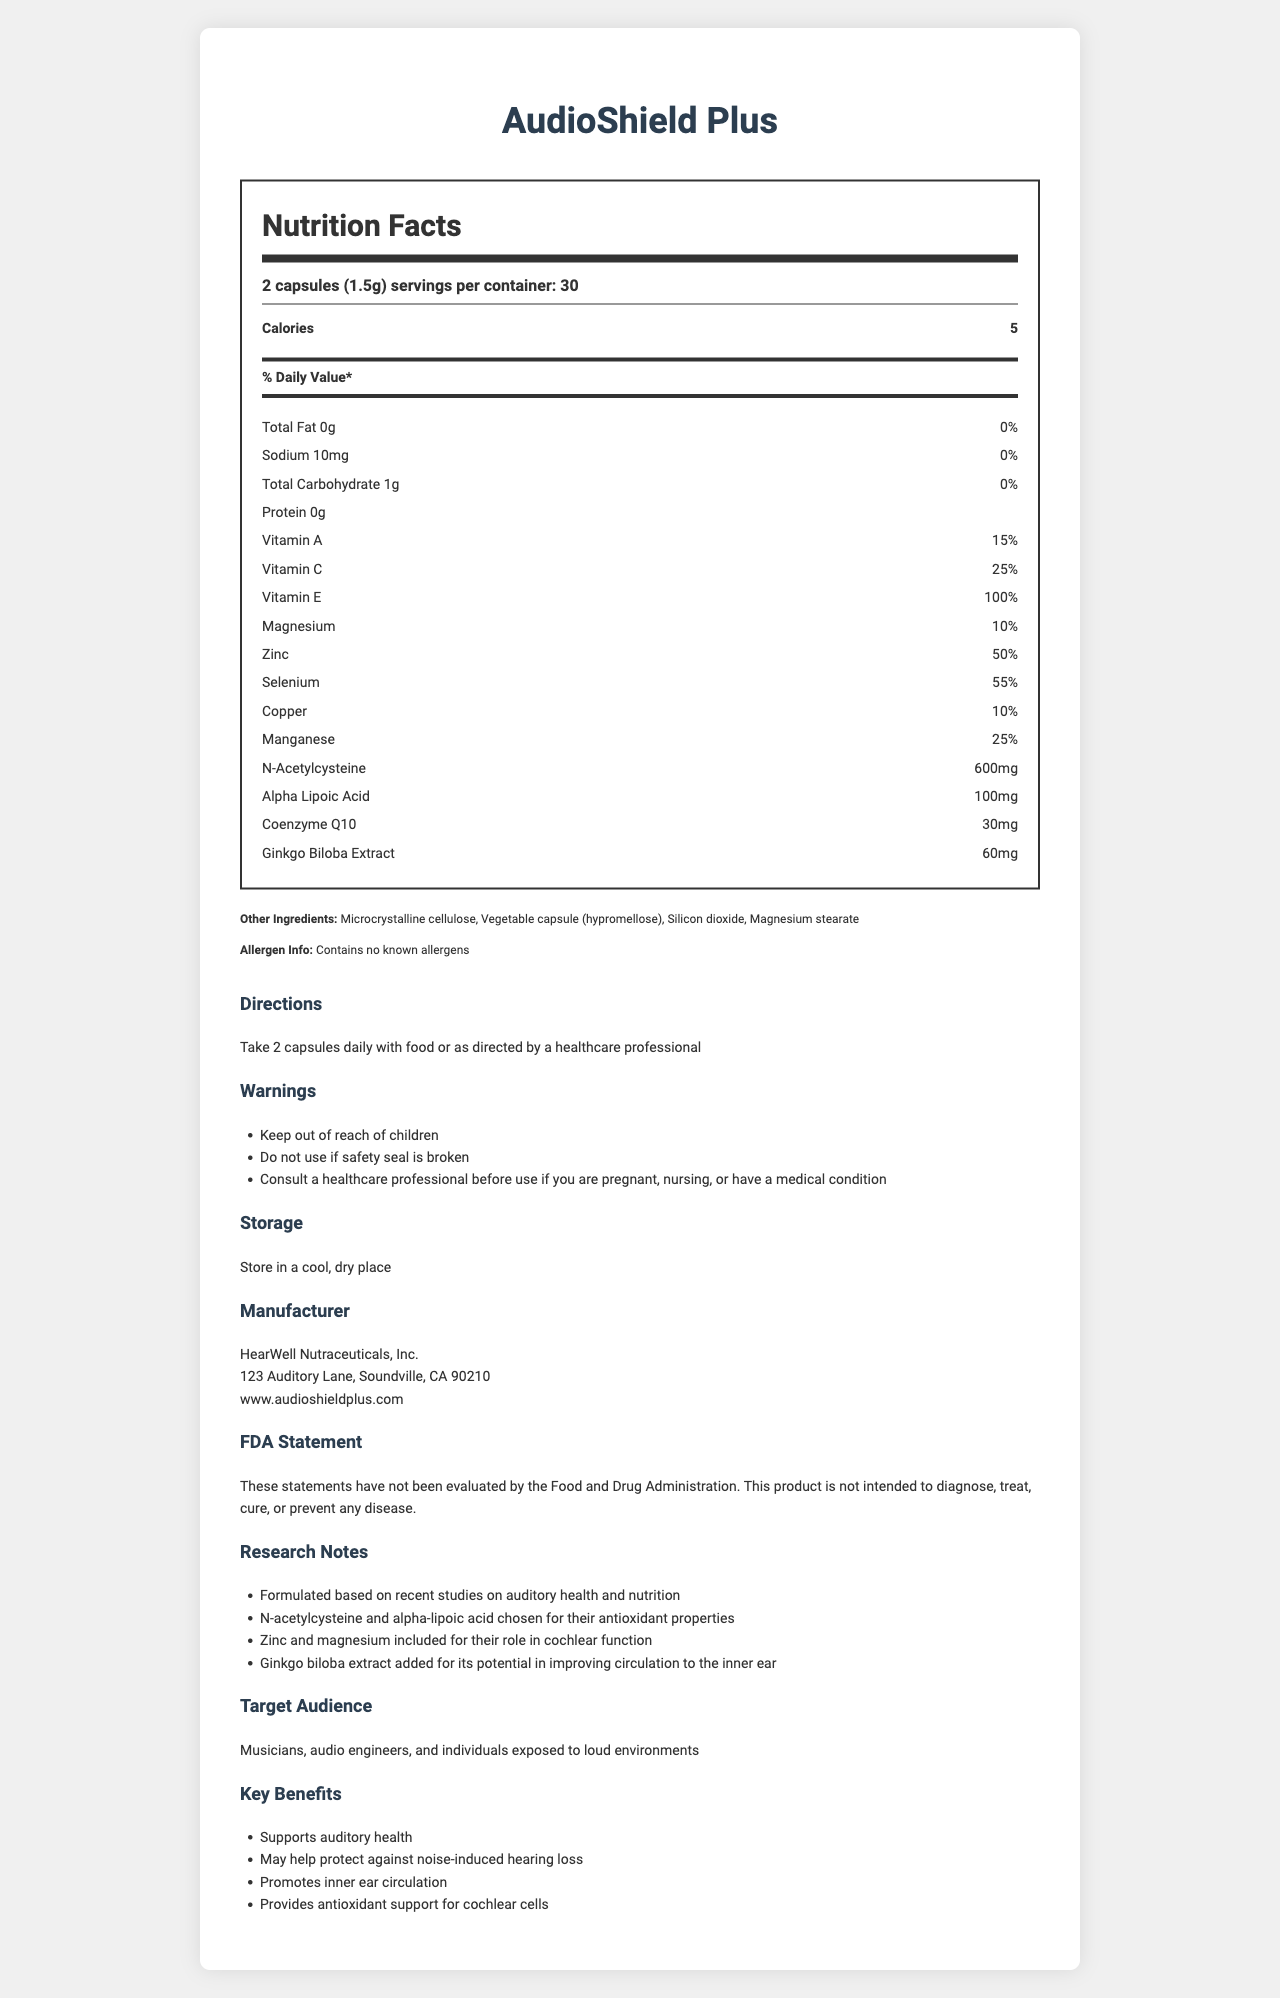what is the serving size of AudioShield Plus? The document states that the serving size is "2 capsules (1.5g)".
Answer: 2 capsules (1.5g) how many servings per container are there? The document mentions that there are 30 servings per container.
Answer: 30 how much sodium is in one serving of AudioShield Plus? The document lists sodium content as 10mg per serving.
Answer: 10mg what is the percentage of daily value for Vitamin E in AudioShield Plus? The document specifies that Vitamin E contributes 100% of the daily value.
Answer: 100% does AudioShield Plus contain any known allergens? The allergen information in the document states: "Contains no known allergens."
Answer: No what are the three main ingredients in the 'other ingredients' list? A. Rice bran, Vegetable capsule, Magnesium stearate B. Microcrystalline cellulose, Vegetable capsule, Silicon dioxide C. Microcrystalline cellulose, Gelatin, Silicon dioxide D. Rice powder, Gelatin, Silicon dioxide The document lists the 'other ingredients' as "Microcrystalline cellulose, Vegetable capsule (hypromellose), Silicon dioxide, Magnesium stearate".
Answer: B what is the primary purpose of including Ginkgo Biloba Extract in the supplement? A. To enhance memory B. To boost energy levels C. To improve circulation to the inner ear D. To provide dietary fiber According to the research notes, Ginkgo Biloba Extract is included for its potential in improving circulation to the inner ear.
Answer: C is this product recommended for pregnant women without consulting a healthcare professional? The document contains a warning to consult a healthcare professional before use if you are pregnant, nursing, or have a medical condition.
Answer: No how much n-acetylcysteine is in each serving? The nutrition facts label lists the amount of n-acetylcysteine as 600mg per serving.
Answer: 600mg where is HearWell Nutraceuticals, Inc. located? The address provided in the document is "123 Auditory Lane, Soundville, CA 90210".
Answer: 123 Auditory Lane, Soundville, CA 90210 summarize the key benefits of AudioShield Plus. The document lists these benefits under the key benefits section of the additional information.
Answer: AudioShield Plus supports auditory health, may help protect against noise-induced hearing loss, promotes inner ear circulation, and provides antioxidant support for cochlear cells. how many calories are in a serving of AudioShield Plus? The nutrition label specifies that there are 5 calories per serving.
Answer: 5 can the specific formulation chosen for antioxidants be determined from the document? The document mentions that n-acetylcysteine and alpha-lipoic acid were chosen for their antioxidant properties.
Answer: Yes what is not known about the FDA's evaluation of the product? The document includes a statement that the claims about the product have not been evaluated by the FDA.
Answer: These statements have not been evaluated by the Food and Drug Administration. does the product contain any form of magnesium? The nutrition facts label lists magnesium, which constitutes 10% of the daily value.
Answer: Yes which of the following is not included as a benefit of AudioShield Plus? A. Supports auditory health B. Improves vision C. May help protect against noise-induced hearing loss D. Promotes inner ear circulation The improvement of vision is not mentioned as one of the benefits in the document. The listed benefits are related to auditory health, protection from noise-induced hearing loss, and inner ear circulation.
Answer: B 